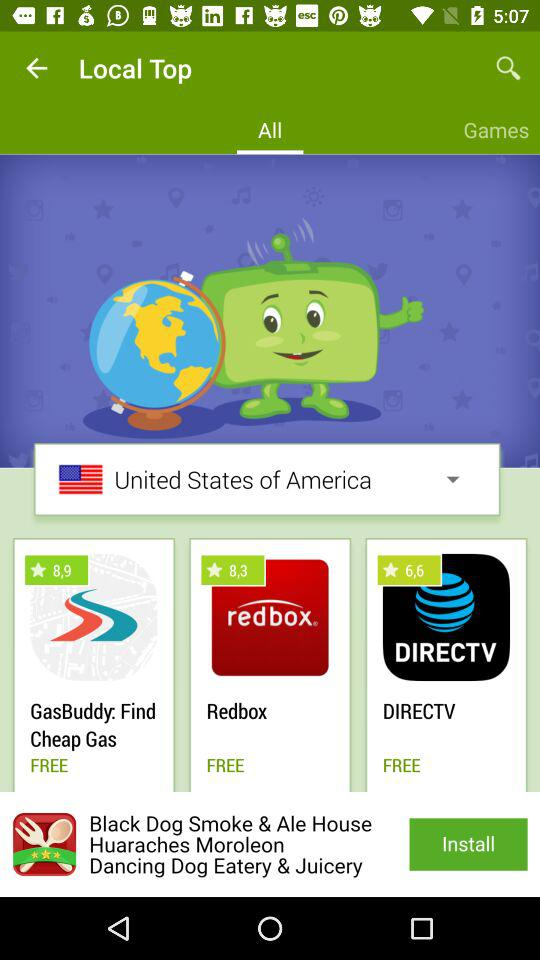Which tab is selected? The selected tab is "All". 